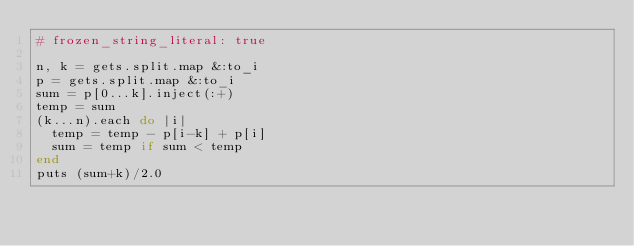<code> <loc_0><loc_0><loc_500><loc_500><_Ruby_># frozen_string_literal: true

n, k = gets.split.map &:to_i
p = gets.split.map &:to_i
sum = p[0...k].inject(:+)
temp = sum
(k...n).each do |i|
  temp = temp - p[i-k] + p[i]
  sum = temp if sum < temp
end
puts (sum+k)/2.0
</code> 